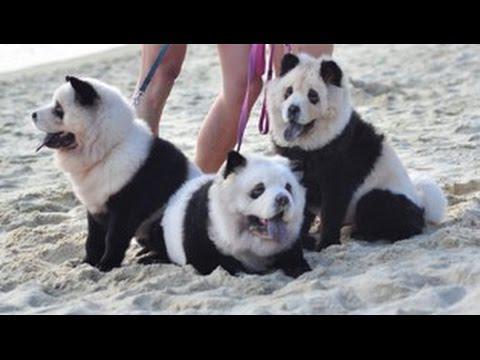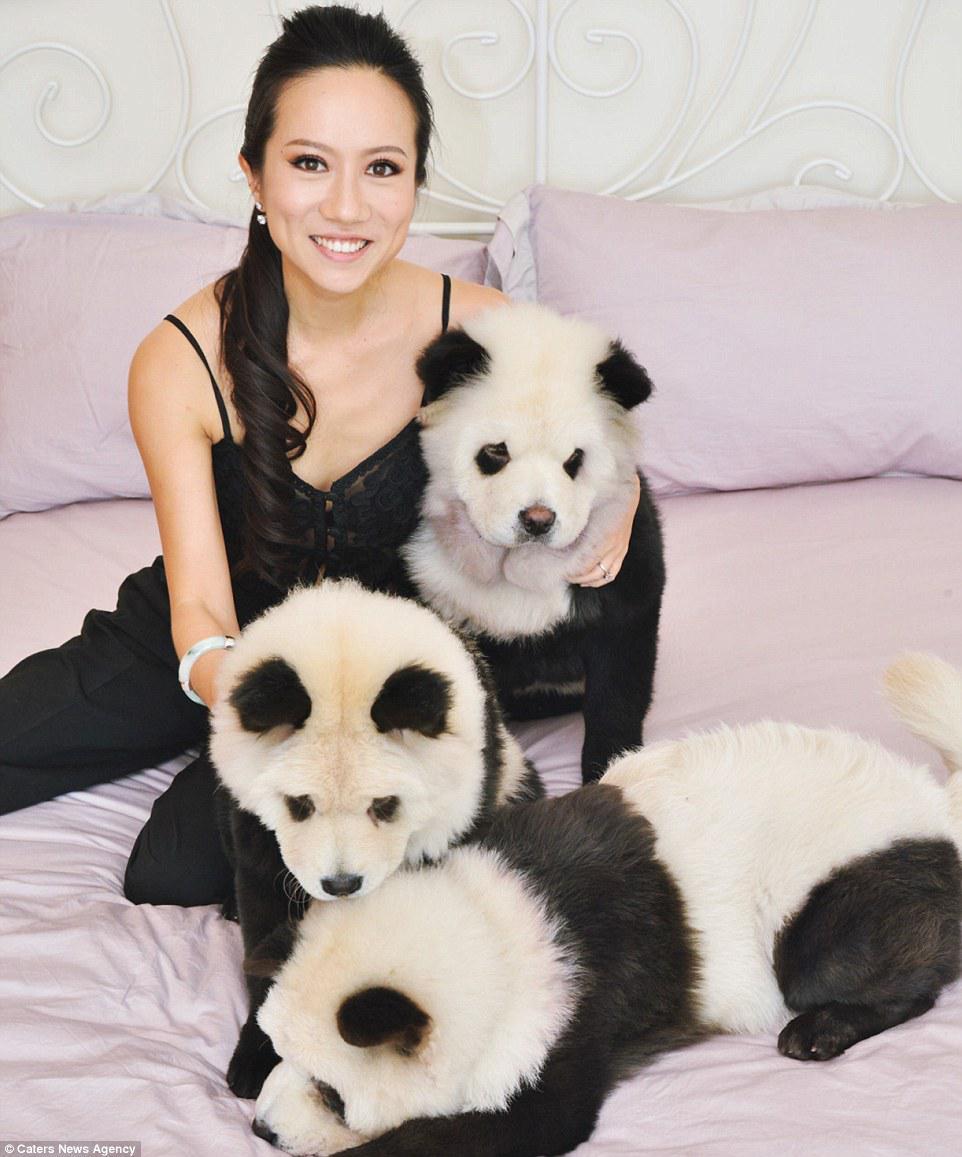The first image is the image on the left, the second image is the image on the right. Examine the images to the left and right. Is the description "In one image, a woman poses with three dogs" accurate? Answer yes or no. Yes. The first image is the image on the left, the second image is the image on the right. Assess this claim about the two images: "A woman is hugging dogs dyes to look like pandas". Correct or not? Answer yes or no. Yes. 